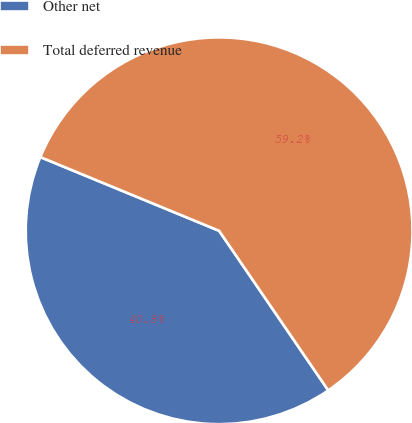Convert chart. <chart><loc_0><loc_0><loc_500><loc_500><pie_chart><fcel>Other net<fcel>Total deferred revenue<nl><fcel>40.77%<fcel>59.23%<nl></chart> 